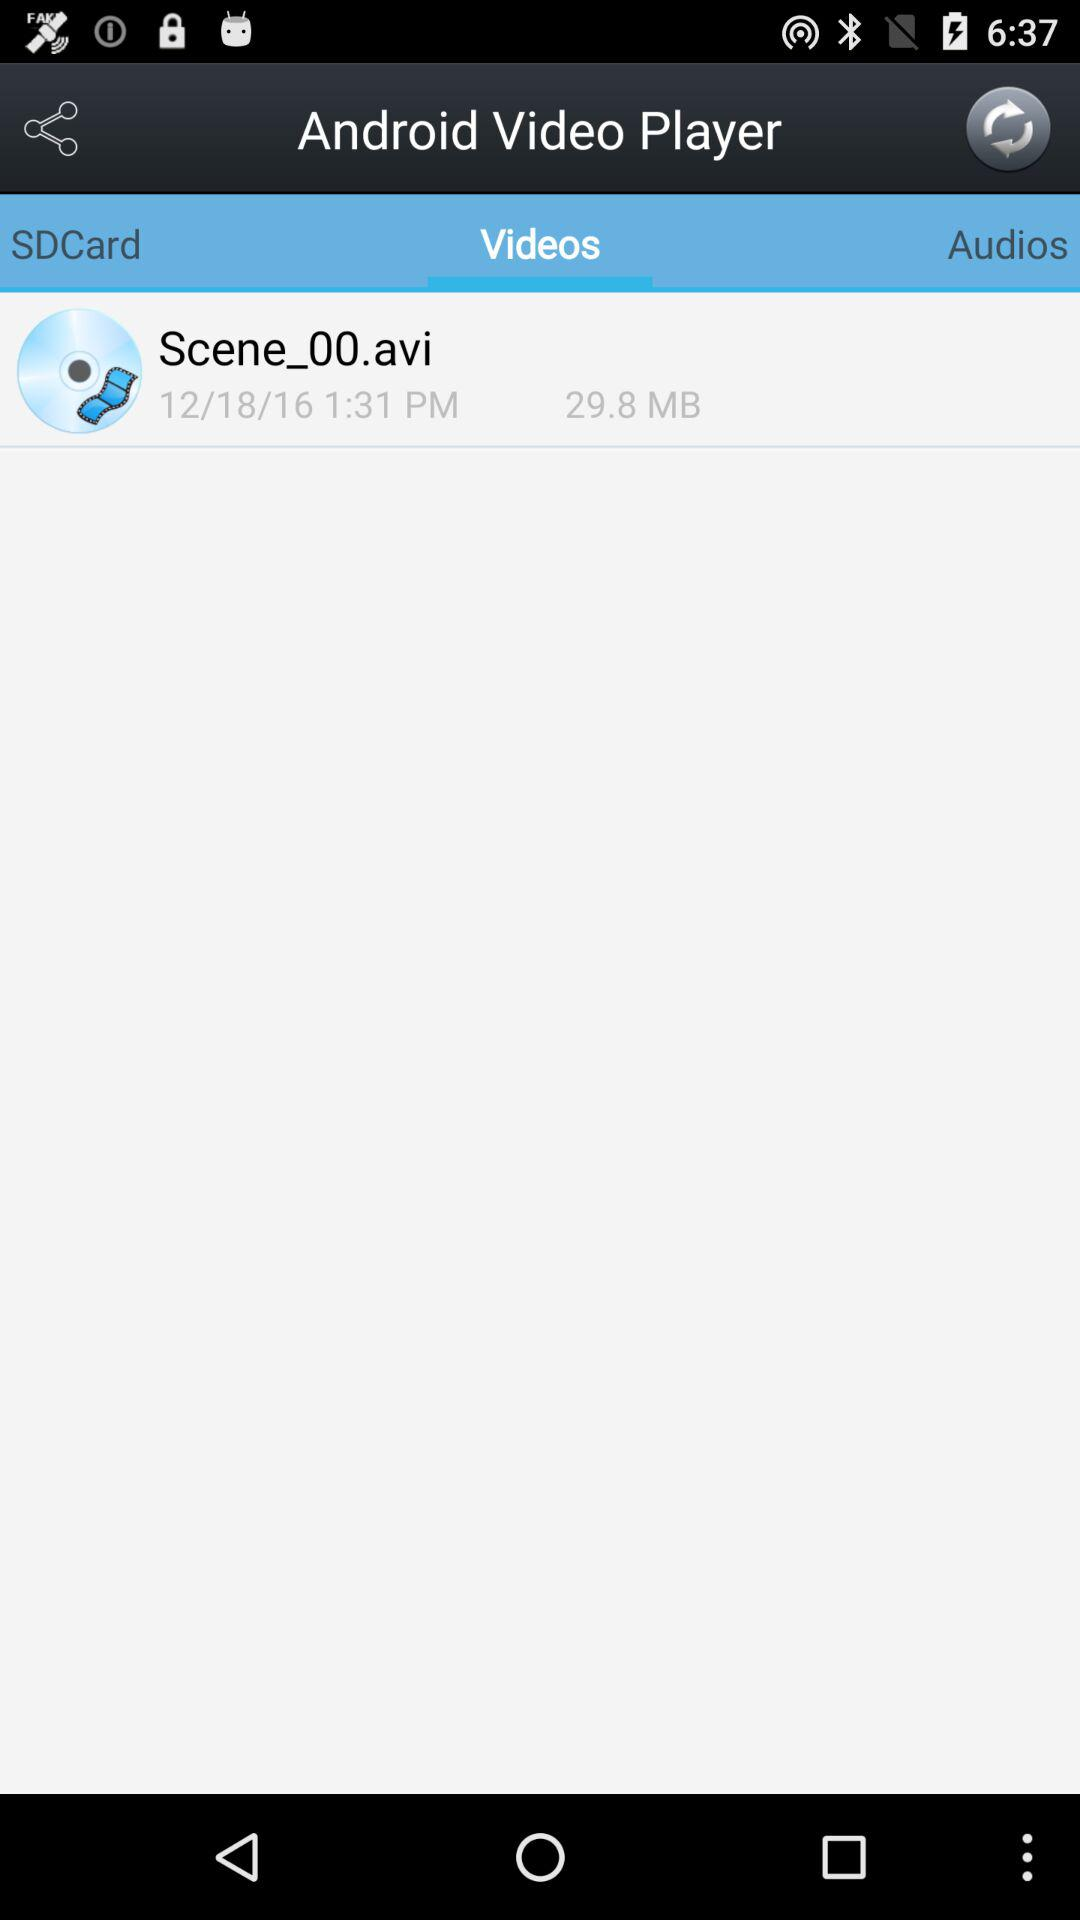What is the given time? The given time is 1:31 PM. 